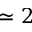<formula> <loc_0><loc_0><loc_500><loc_500>\simeq 2</formula> 